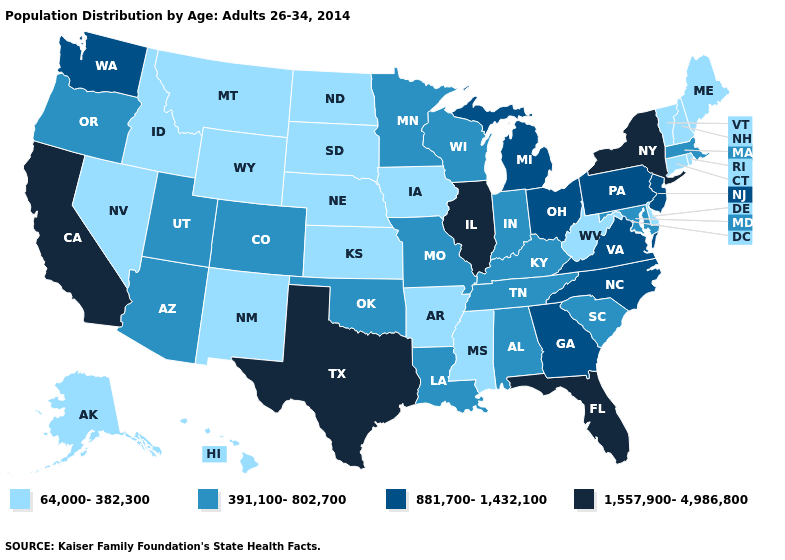Does Delaware have a lower value than West Virginia?
Write a very short answer. No. What is the value of Texas?
Answer briefly. 1,557,900-4,986,800. Among the states that border Ohio , does Kentucky have the lowest value?
Give a very brief answer. No. Among the states that border Utah , does Arizona have the lowest value?
Give a very brief answer. No. Among the states that border North Dakota , does South Dakota have the lowest value?
Be succinct. Yes. What is the lowest value in the USA?
Answer briefly. 64,000-382,300. Does the map have missing data?
Concise answer only. No. Name the states that have a value in the range 881,700-1,432,100?
Short answer required. Georgia, Michigan, New Jersey, North Carolina, Ohio, Pennsylvania, Virginia, Washington. What is the value of New Hampshire?
Give a very brief answer. 64,000-382,300. Name the states that have a value in the range 881,700-1,432,100?
Answer briefly. Georgia, Michigan, New Jersey, North Carolina, Ohio, Pennsylvania, Virginia, Washington. What is the value of North Dakota?
Concise answer only. 64,000-382,300. What is the lowest value in the USA?
Be succinct. 64,000-382,300. Is the legend a continuous bar?
Short answer required. No. How many symbols are there in the legend?
Concise answer only. 4. 